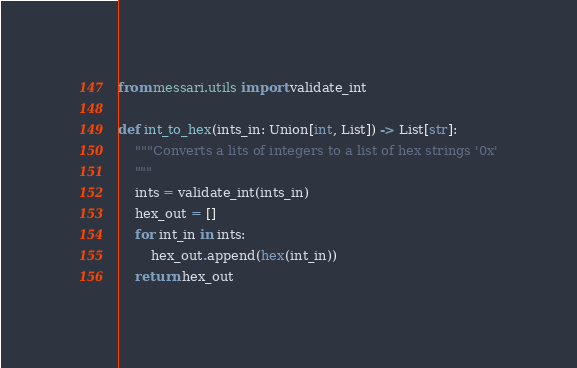<code> <loc_0><loc_0><loc_500><loc_500><_Python_>from messari.utils import validate_int

def int_to_hex(ints_in: Union[int, List]) -> List[str]:
    """Converts a lits of integers to a list of hex strings '0x'
    """
    ints = validate_int(ints_in)
    hex_out = []
    for int_in in ints:
        hex_out.append(hex(int_in))
    return hex_out
</code> 